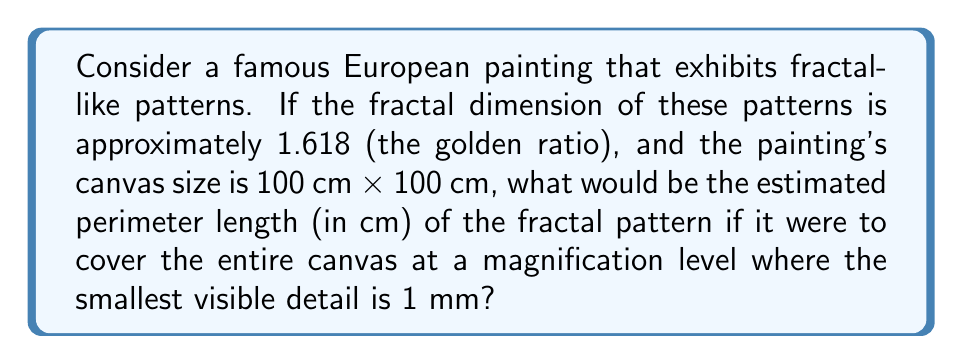Can you answer this question? Let's approach this step-by-step:

1) The fractal dimension (D) is given as 1.618. This is between 1 (a line) and 2 (a filled plane), indicating a complex, self-similar pattern.

2) The canvas size is 100 cm x 100 cm, so the area (A) is 10,000 cm².

3) The smallest visible detail is 1 mm = 0.1 cm. This represents our measurement scale (ε).

4) For a fractal curve, the relationship between the measured length (L) and the measurement scale (ε) is given by:

   $$ L(\varepsilon) = k \cdot \varepsilon^{1-D} $$

   where k is a constant and D is the fractal dimension.

5) We don't know k, but we can estimate it using the canvas area:

   $$ A = k \cdot \varepsilon^{2-D} $$

6) Substituting our values:

   $$ 10000 = k \cdot 0.1^{2-1.618} $$
   $$ 10000 = k \cdot 0.1^{0.382} $$
   $$ k = \frac{10000}{0.1^{0.382}} \approx 39810.71 $$

7) Now we can use this k to find L:

   $$ L(0.1) = 39810.71 \cdot 0.1^{1-1.618} $$
   $$ L(0.1) = 39810.71 \cdot 0.1^{-0.618} $$
   $$ L(0.1) \approx 1585.29 \text{ cm} $$

Therefore, the estimated perimeter length of the fractal pattern is approximately 1585.29 cm.
Answer: 1585.29 cm 